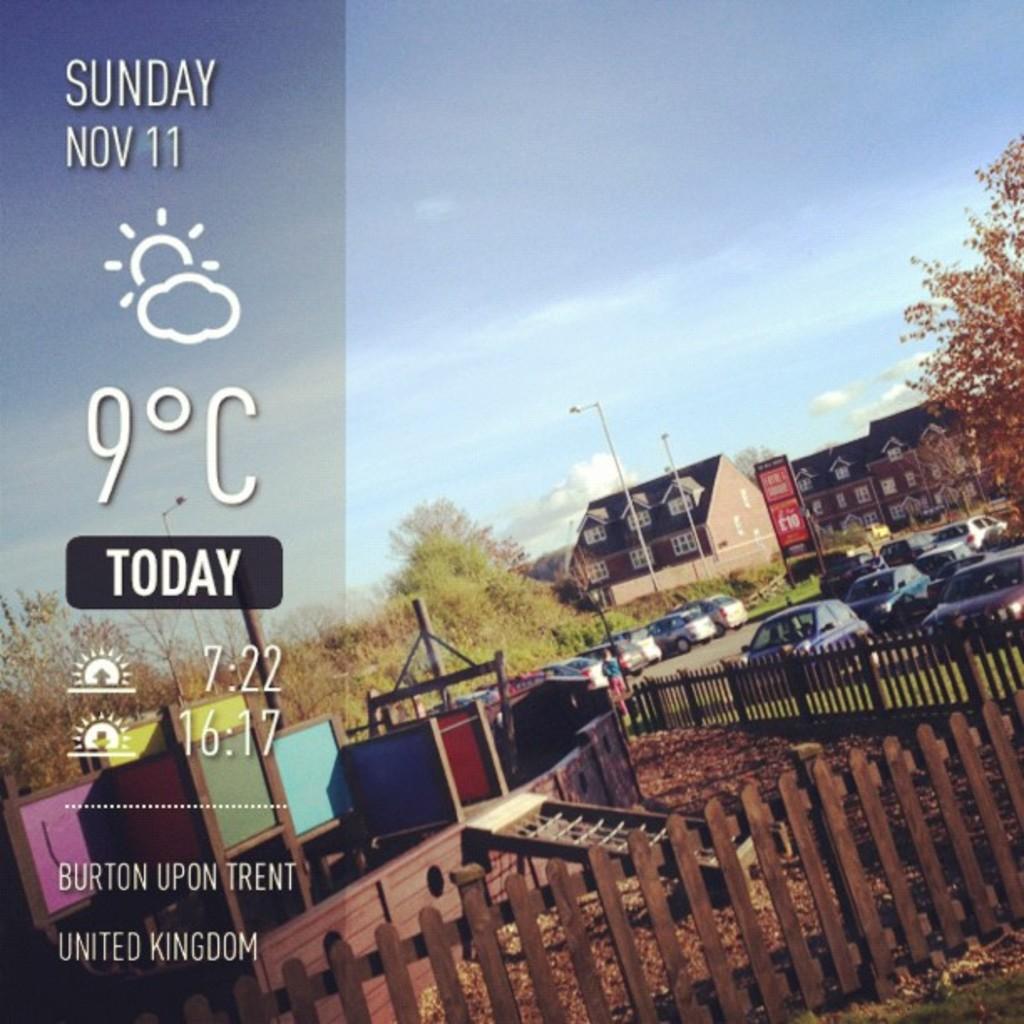What date is the weather for?
Your answer should be very brief. Nov 11. 